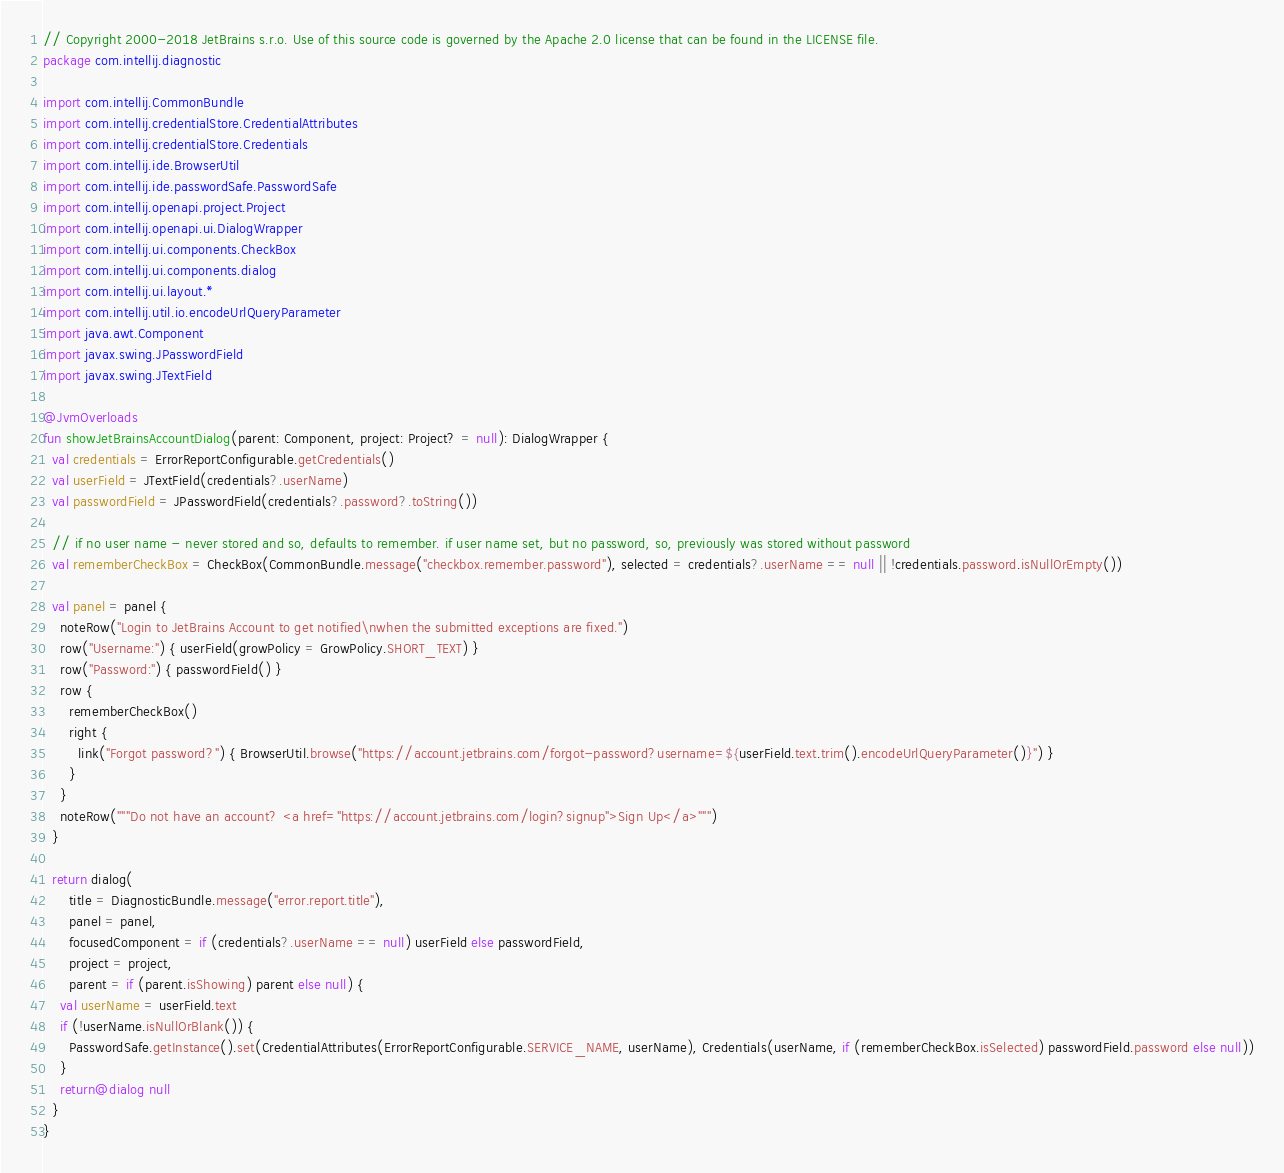Convert code to text. <code><loc_0><loc_0><loc_500><loc_500><_Kotlin_>// Copyright 2000-2018 JetBrains s.r.o. Use of this source code is governed by the Apache 2.0 license that can be found in the LICENSE file.
package com.intellij.diagnostic

import com.intellij.CommonBundle
import com.intellij.credentialStore.CredentialAttributes
import com.intellij.credentialStore.Credentials
import com.intellij.ide.BrowserUtil
import com.intellij.ide.passwordSafe.PasswordSafe
import com.intellij.openapi.project.Project
import com.intellij.openapi.ui.DialogWrapper
import com.intellij.ui.components.CheckBox
import com.intellij.ui.components.dialog
import com.intellij.ui.layout.*
import com.intellij.util.io.encodeUrlQueryParameter
import java.awt.Component
import javax.swing.JPasswordField
import javax.swing.JTextField

@JvmOverloads
fun showJetBrainsAccountDialog(parent: Component, project: Project? = null): DialogWrapper {
  val credentials = ErrorReportConfigurable.getCredentials()
  val userField = JTextField(credentials?.userName)
  val passwordField = JPasswordField(credentials?.password?.toString())

  // if no user name - never stored and so, defaults to remember. if user name set, but no password, so, previously was stored without password
  val rememberCheckBox = CheckBox(CommonBundle.message("checkbox.remember.password"), selected = credentials?.userName == null || !credentials.password.isNullOrEmpty())

  val panel = panel {
    noteRow("Login to JetBrains Account to get notified\nwhen the submitted exceptions are fixed.")
    row("Username:") { userField(growPolicy = GrowPolicy.SHORT_TEXT) }
    row("Password:") { passwordField() }
    row {
      rememberCheckBox()
      right {
        link("Forgot password?") { BrowserUtil.browse("https://account.jetbrains.com/forgot-password?username=${userField.text.trim().encodeUrlQueryParameter()}") }
      }
    }
    noteRow("""Do not have an account? <a href="https://account.jetbrains.com/login?signup">Sign Up</a>""")
  }

  return dialog(
      title = DiagnosticBundle.message("error.report.title"),
      panel = panel,
      focusedComponent = if (credentials?.userName == null) userField else passwordField,
      project = project,
      parent = if (parent.isShowing) parent else null) {
    val userName = userField.text
    if (!userName.isNullOrBlank()) {
      PasswordSafe.getInstance().set(CredentialAttributes(ErrorReportConfigurable.SERVICE_NAME, userName), Credentials(userName, if (rememberCheckBox.isSelected) passwordField.password else null))
    }
    return@dialog null
  }
}</code> 